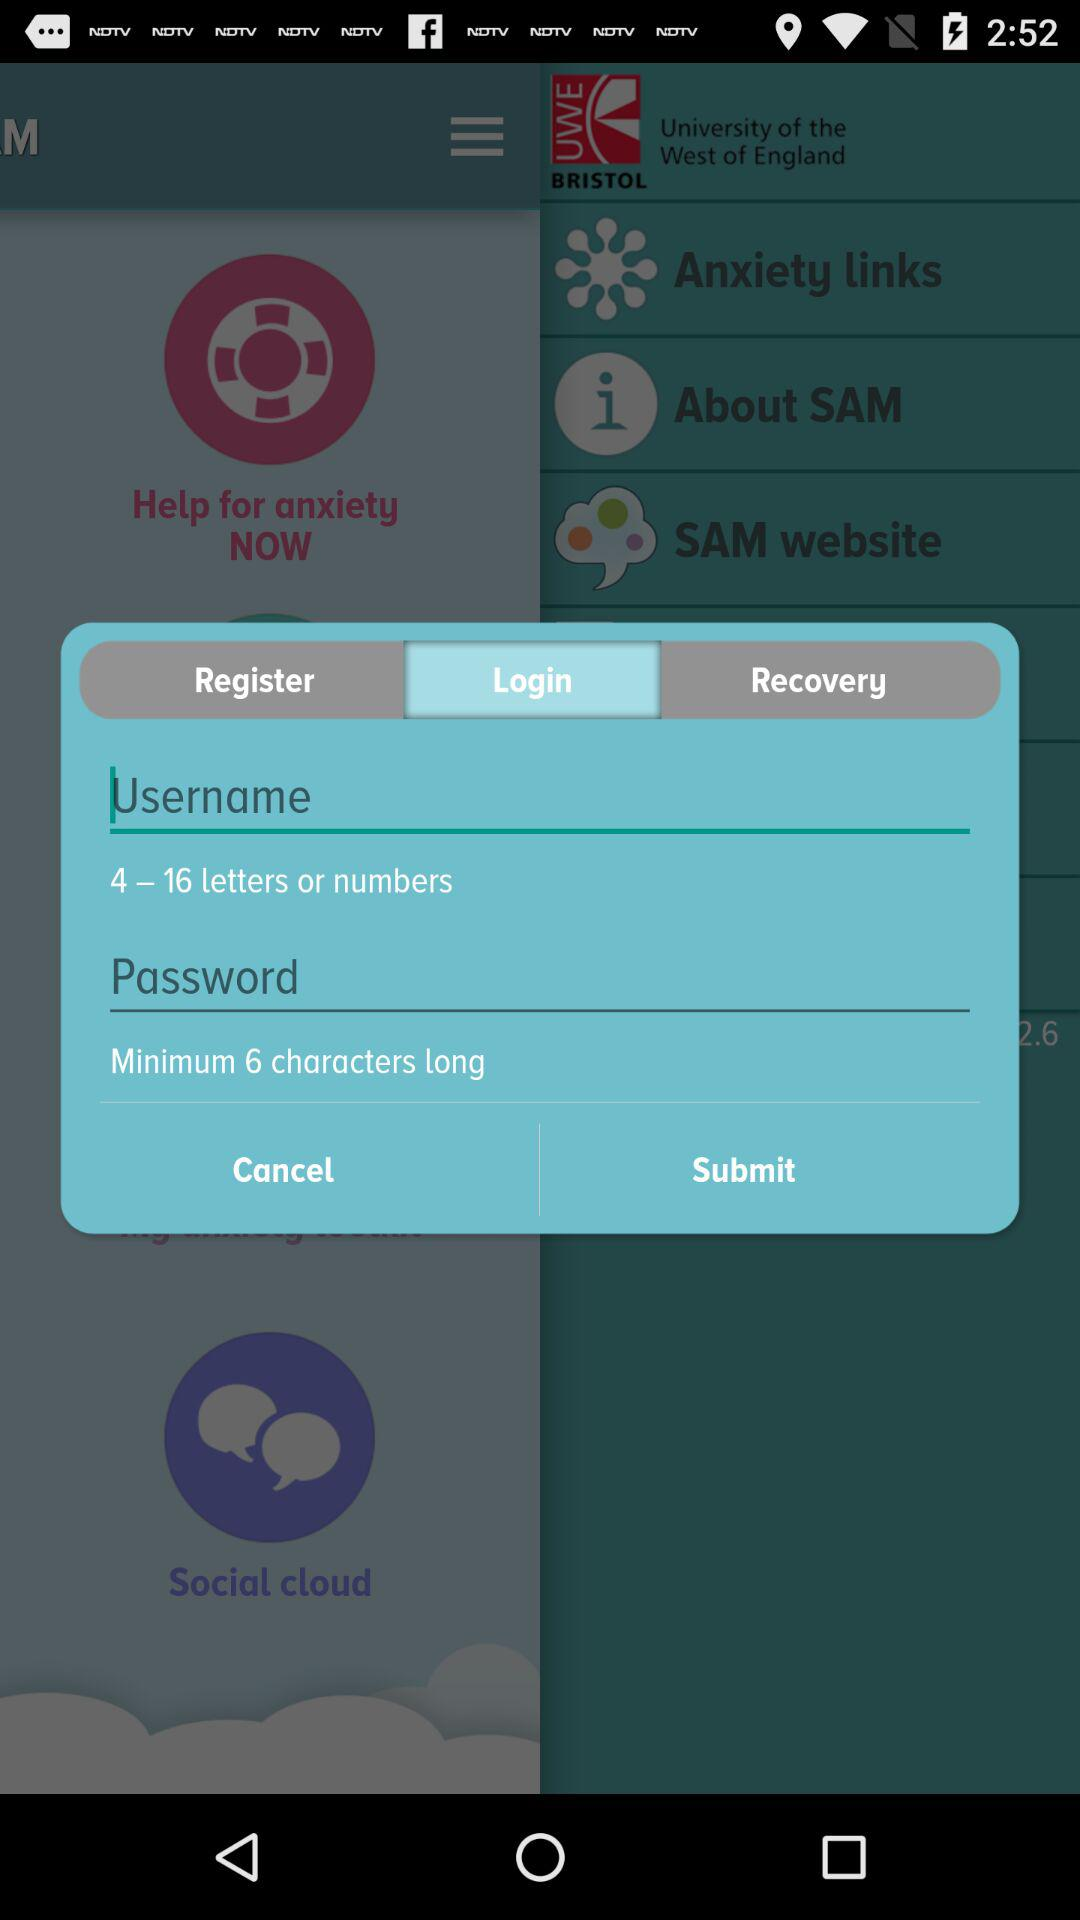What is the instruction for the length of the username? The instructions for the length of the username are 4-16 letters or numbers. 